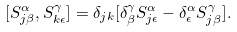<formula> <loc_0><loc_0><loc_500><loc_500>[ S ^ { \alpha } _ { j \beta } , S ^ { \gamma } _ { k \epsilon } ] = \delta _ { j k } [ \delta _ { \beta } ^ { \gamma } S ^ { \alpha } _ { j \epsilon } - \delta _ { \epsilon } ^ { \alpha } S ^ { \gamma } _ { j \beta } ] .</formula> 